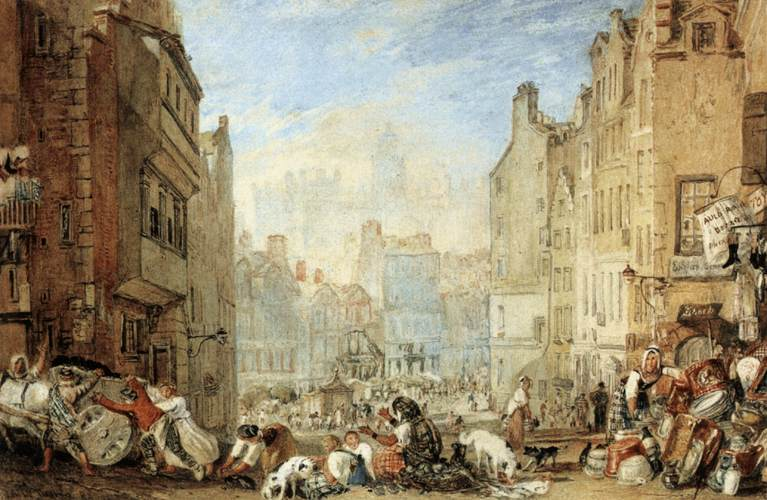What can you infer about the historical period of this painting? The painting appears to be from the 18th or 19th century, indicated by the clothing styles of the people and the architectural design of the buildings. The presence of street vendors, the design of the carts, and the overall atmosphere suggest a historical European city. Additionally, the absence of modern transportation like cars suggests this scene predates the 20th century. Can you describe the types of activities the people in the painting are engaged in? Certainly! The painting depicts a variety of activities. On the left, individuals are seen pulling carts, possibly unloading goods to sell. In the center, a group of women is gathered, perhaps conversing or trading items. Children are playing on the street, adding a vibrant energy to the scene. On the right, more women are busy, some with what appear to be laundry baskets or containers. Everyone seems engaged in their daily routines, contributing to the lively atmosphere of the market street. 